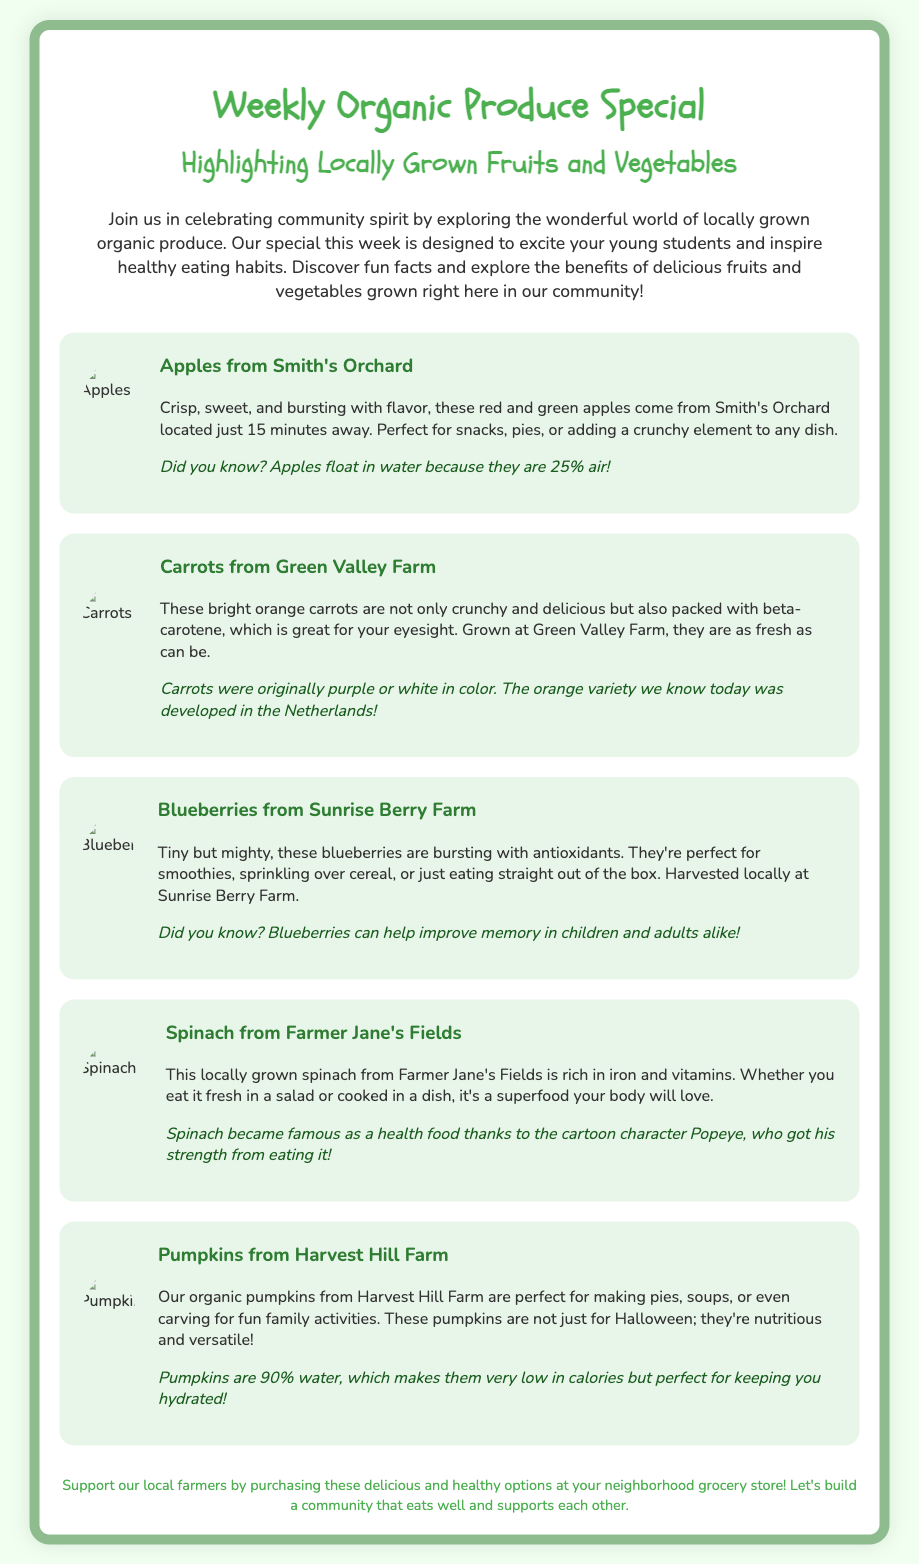what is the title of the event? The title of the event is presented at the top of the document.
Answer: Weekly Organic Produce Special how many produce items are highlighted? The document lists five different produce items.
Answer: 5 where do the apples come from? The document mentions the source of the apples in the description.
Answer: Smith's Orchard which vegetable is known for improving eyesight? This information is provided in the description of the carrots.
Answer: Carrots what fun fact is associated with blueberries? The fun fact regarding blueberries is included in the produce description.
Answer: Blueberries can help improve memory in children and adults alike! what percentage of water are pumpkins? The document provides this specific fact in the description of pumpkins.
Answer: 90% which character popularized spinach as a health food? The document references a famous character related to spinach in the fun fact.
Answer: Popeye what is the primary color of the carrots mentioned? The description of the carrots specifies their color.
Answer: Orange 